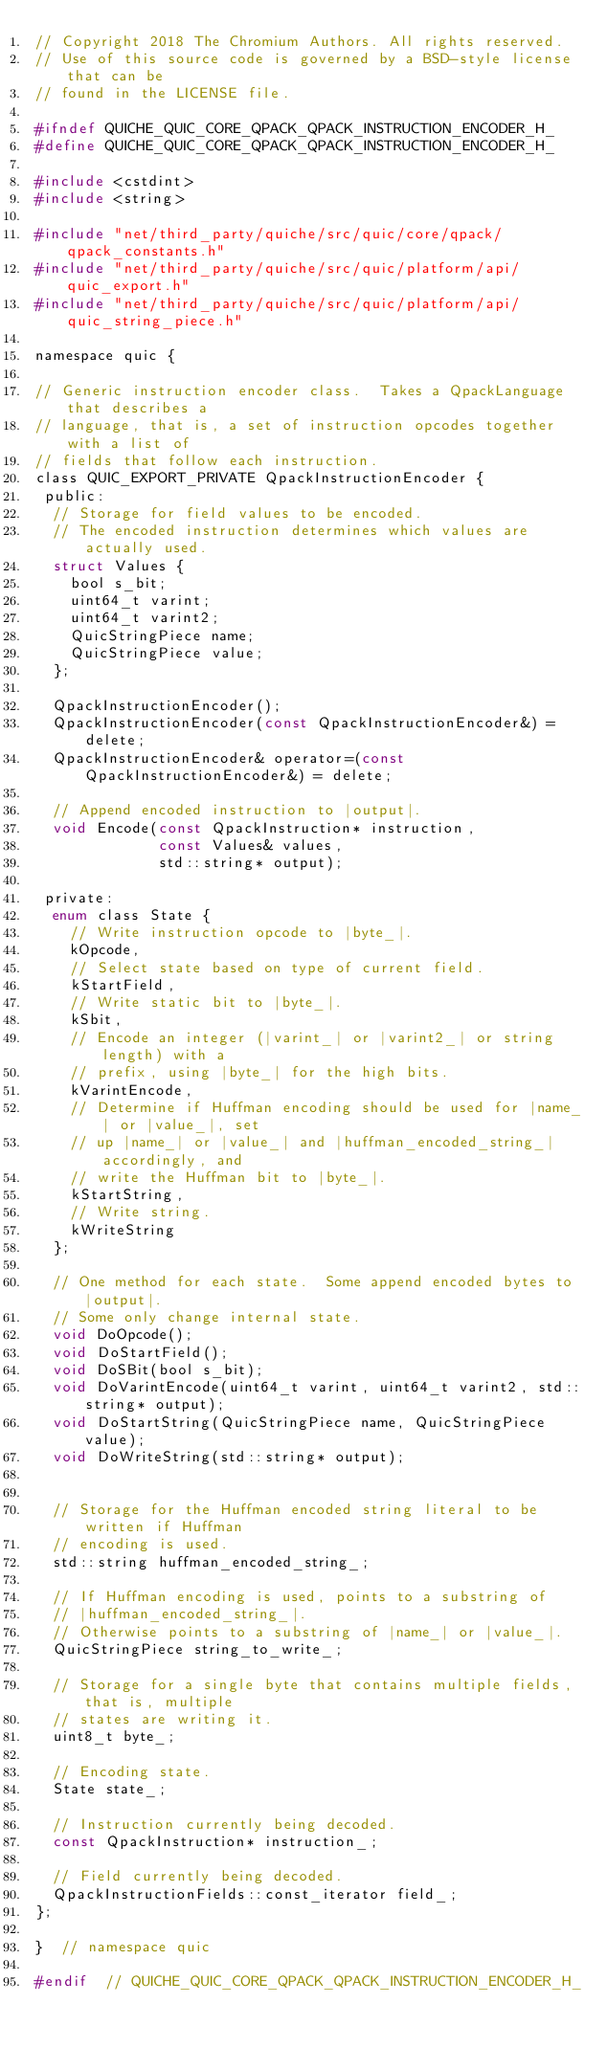Convert code to text. <code><loc_0><loc_0><loc_500><loc_500><_C_>// Copyright 2018 The Chromium Authors. All rights reserved.
// Use of this source code is governed by a BSD-style license that can be
// found in the LICENSE file.

#ifndef QUICHE_QUIC_CORE_QPACK_QPACK_INSTRUCTION_ENCODER_H_
#define QUICHE_QUIC_CORE_QPACK_QPACK_INSTRUCTION_ENCODER_H_

#include <cstdint>
#include <string>

#include "net/third_party/quiche/src/quic/core/qpack/qpack_constants.h"
#include "net/third_party/quiche/src/quic/platform/api/quic_export.h"
#include "net/third_party/quiche/src/quic/platform/api/quic_string_piece.h"

namespace quic {

// Generic instruction encoder class.  Takes a QpackLanguage that describes a
// language, that is, a set of instruction opcodes together with a list of
// fields that follow each instruction.
class QUIC_EXPORT_PRIVATE QpackInstructionEncoder {
 public:
  // Storage for field values to be encoded.
  // The encoded instruction determines which values are actually used.
  struct Values {
    bool s_bit;
    uint64_t varint;
    uint64_t varint2;
    QuicStringPiece name;
    QuicStringPiece value;
  };

  QpackInstructionEncoder();
  QpackInstructionEncoder(const QpackInstructionEncoder&) = delete;
  QpackInstructionEncoder& operator=(const QpackInstructionEncoder&) = delete;

  // Append encoded instruction to |output|.
  void Encode(const QpackInstruction* instruction,
              const Values& values,
              std::string* output);

 private:
  enum class State {
    // Write instruction opcode to |byte_|.
    kOpcode,
    // Select state based on type of current field.
    kStartField,
    // Write static bit to |byte_|.
    kSbit,
    // Encode an integer (|varint_| or |varint2_| or string length) with a
    // prefix, using |byte_| for the high bits.
    kVarintEncode,
    // Determine if Huffman encoding should be used for |name_| or |value_|, set
    // up |name_| or |value_| and |huffman_encoded_string_| accordingly, and
    // write the Huffman bit to |byte_|.
    kStartString,
    // Write string.
    kWriteString
  };

  // One method for each state.  Some append encoded bytes to |output|.
  // Some only change internal state.
  void DoOpcode();
  void DoStartField();
  void DoSBit(bool s_bit);
  void DoVarintEncode(uint64_t varint, uint64_t varint2, std::string* output);
  void DoStartString(QuicStringPiece name, QuicStringPiece value);
  void DoWriteString(std::string* output);


  // Storage for the Huffman encoded string literal to be written if Huffman
  // encoding is used.
  std::string huffman_encoded_string_;

  // If Huffman encoding is used, points to a substring of
  // |huffman_encoded_string_|.
  // Otherwise points to a substring of |name_| or |value_|.
  QuicStringPiece string_to_write_;

  // Storage for a single byte that contains multiple fields, that is, multiple
  // states are writing it.
  uint8_t byte_;

  // Encoding state.
  State state_;

  // Instruction currently being decoded.
  const QpackInstruction* instruction_;

  // Field currently being decoded.
  QpackInstructionFields::const_iterator field_;
};

}  // namespace quic

#endif  // QUICHE_QUIC_CORE_QPACK_QPACK_INSTRUCTION_ENCODER_H_
</code> 